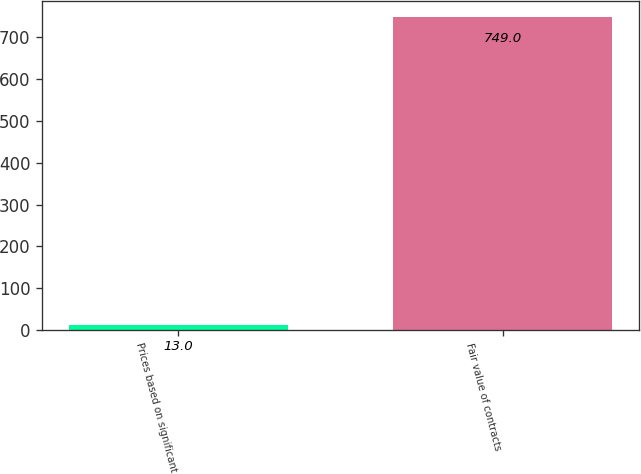<chart> <loc_0><loc_0><loc_500><loc_500><bar_chart><fcel>Prices based on significant<fcel>Fair value of contracts<nl><fcel>13<fcel>749<nl></chart> 